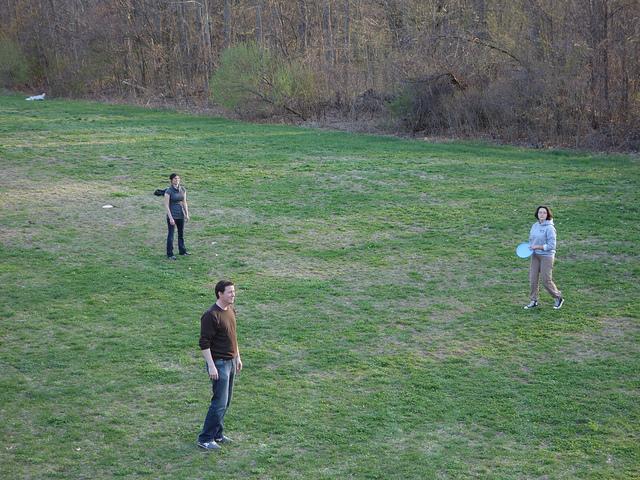What season do you think it is in this picture?
Keep it brief. Fall. What sport are these people playing?
Concise answer only. Frisbee. How many people are pictured?
Answer briefly. 3. 